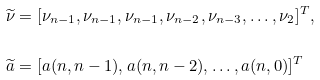Convert formula to latex. <formula><loc_0><loc_0><loc_500><loc_500>\widetilde { \nu } & = [ \nu _ { n - 1 } , \nu _ { n - 1 } , \nu _ { n - 1 } , \nu _ { n - 2 } , \nu _ { n - 3 } , \dots , \nu _ { 2 } ] ^ { T } , \\ \widetilde { a } & = [ a ( n , n - 1 ) , a ( n , n - 2 ) , \dots , a ( n , 0 ) ] ^ { T }</formula> 